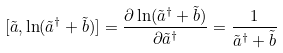Convert formula to latex. <formula><loc_0><loc_0><loc_500><loc_500>[ \tilde { a } , \ln ( \tilde { a } ^ { \dag } + \tilde { b } ) ] = \frac { \partial \ln ( \tilde { a } ^ { \dag } + \tilde { b } ) } { \partial \tilde { a } ^ { \dag } } = \frac { 1 } { \tilde { a } ^ { \dag } + \tilde { b } }</formula> 